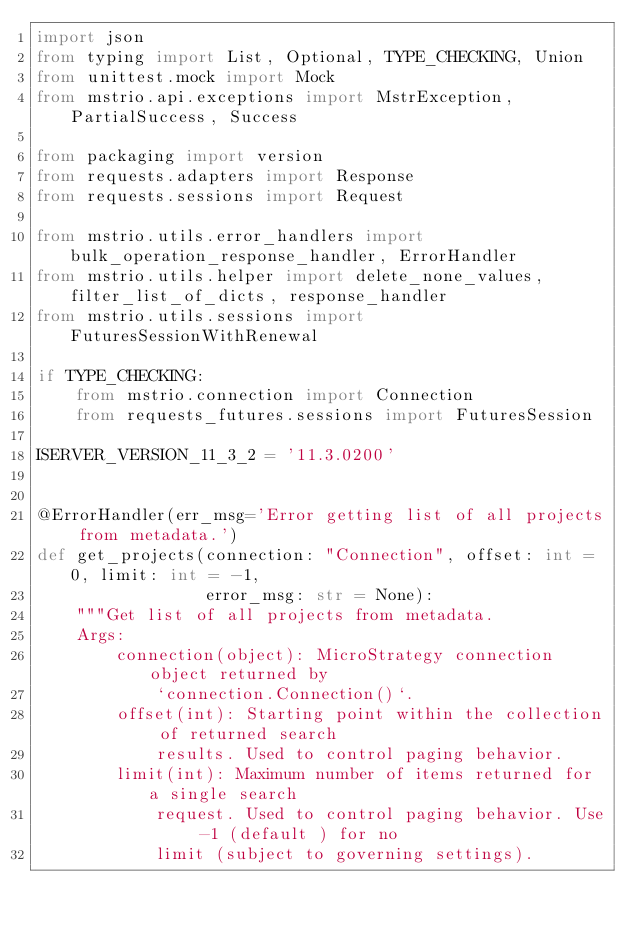Convert code to text. <code><loc_0><loc_0><loc_500><loc_500><_Python_>import json
from typing import List, Optional, TYPE_CHECKING, Union
from unittest.mock import Mock
from mstrio.api.exceptions import MstrException, PartialSuccess, Success

from packaging import version
from requests.adapters import Response
from requests.sessions import Request

from mstrio.utils.error_handlers import bulk_operation_response_handler, ErrorHandler
from mstrio.utils.helper import delete_none_values, filter_list_of_dicts, response_handler
from mstrio.utils.sessions import FuturesSessionWithRenewal

if TYPE_CHECKING:
    from mstrio.connection import Connection
    from requests_futures.sessions import FuturesSession

ISERVER_VERSION_11_3_2 = '11.3.0200'


@ErrorHandler(err_msg='Error getting list of all projects from metadata.')
def get_projects(connection: "Connection", offset: int = 0, limit: int = -1,
                 error_msg: str = None):
    """Get list of all projects from metadata.
    Args:
        connection(object): MicroStrategy connection object returned by
            `connection.Connection()`.
        offset(int): Starting point within the collection of returned search
            results. Used to control paging behavior.
        limit(int): Maximum number of items returned for a single search
            request. Used to control paging behavior. Use -1 (default ) for no
            limit (subject to governing settings).</code> 